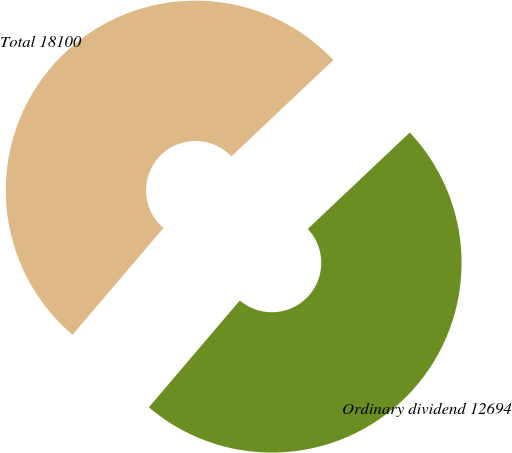<chart> <loc_0><loc_0><loc_500><loc_500><pie_chart><fcel>Ordinary dividend 12694<fcel>Total 18100<nl><fcel>48.28%<fcel>51.72%<nl></chart> 